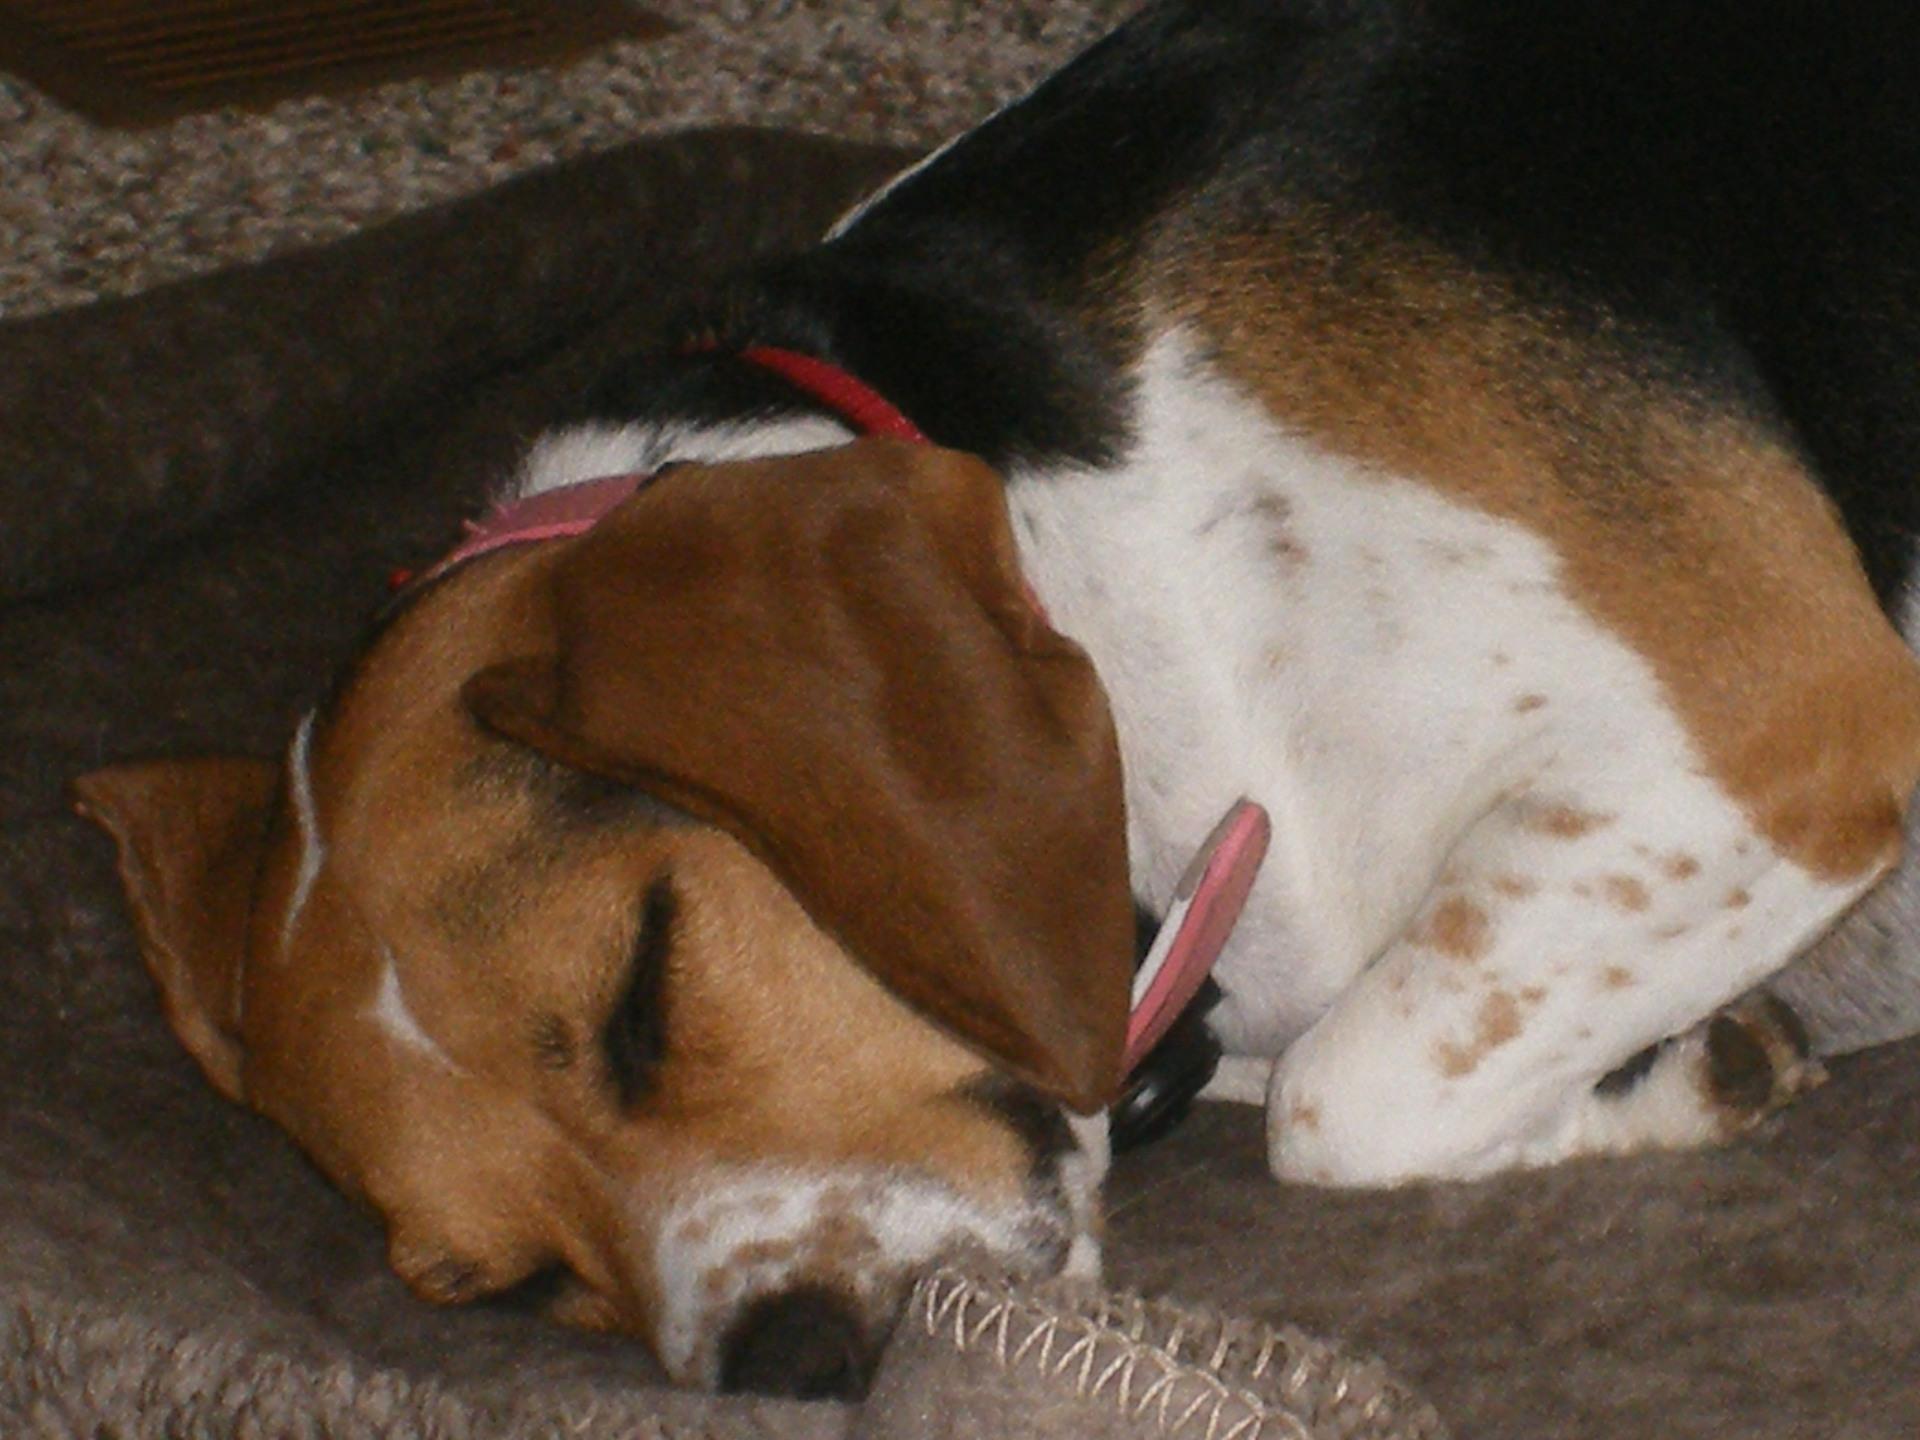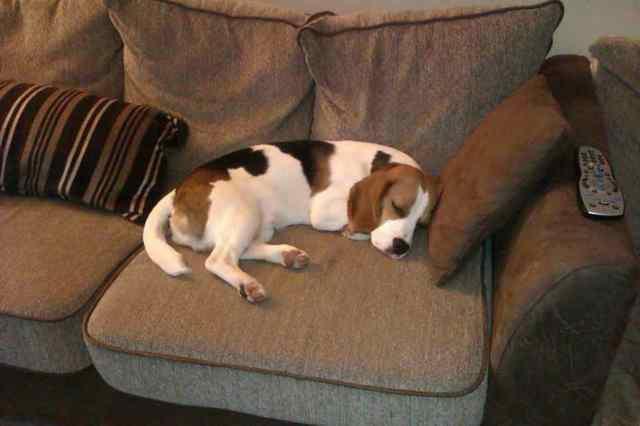The first image is the image on the left, the second image is the image on the right. Analyze the images presented: Is the assertion "There is a one beagle in each picture, all sound asleep." valid? Answer yes or no. Yes. The first image is the image on the left, the second image is the image on the right. For the images shown, is this caption "A dog is sleeping on a couch (sofa)." true? Answer yes or no. Yes. 